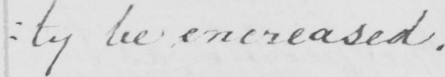Can you tell me what this handwritten text says? : ty be encreased . 